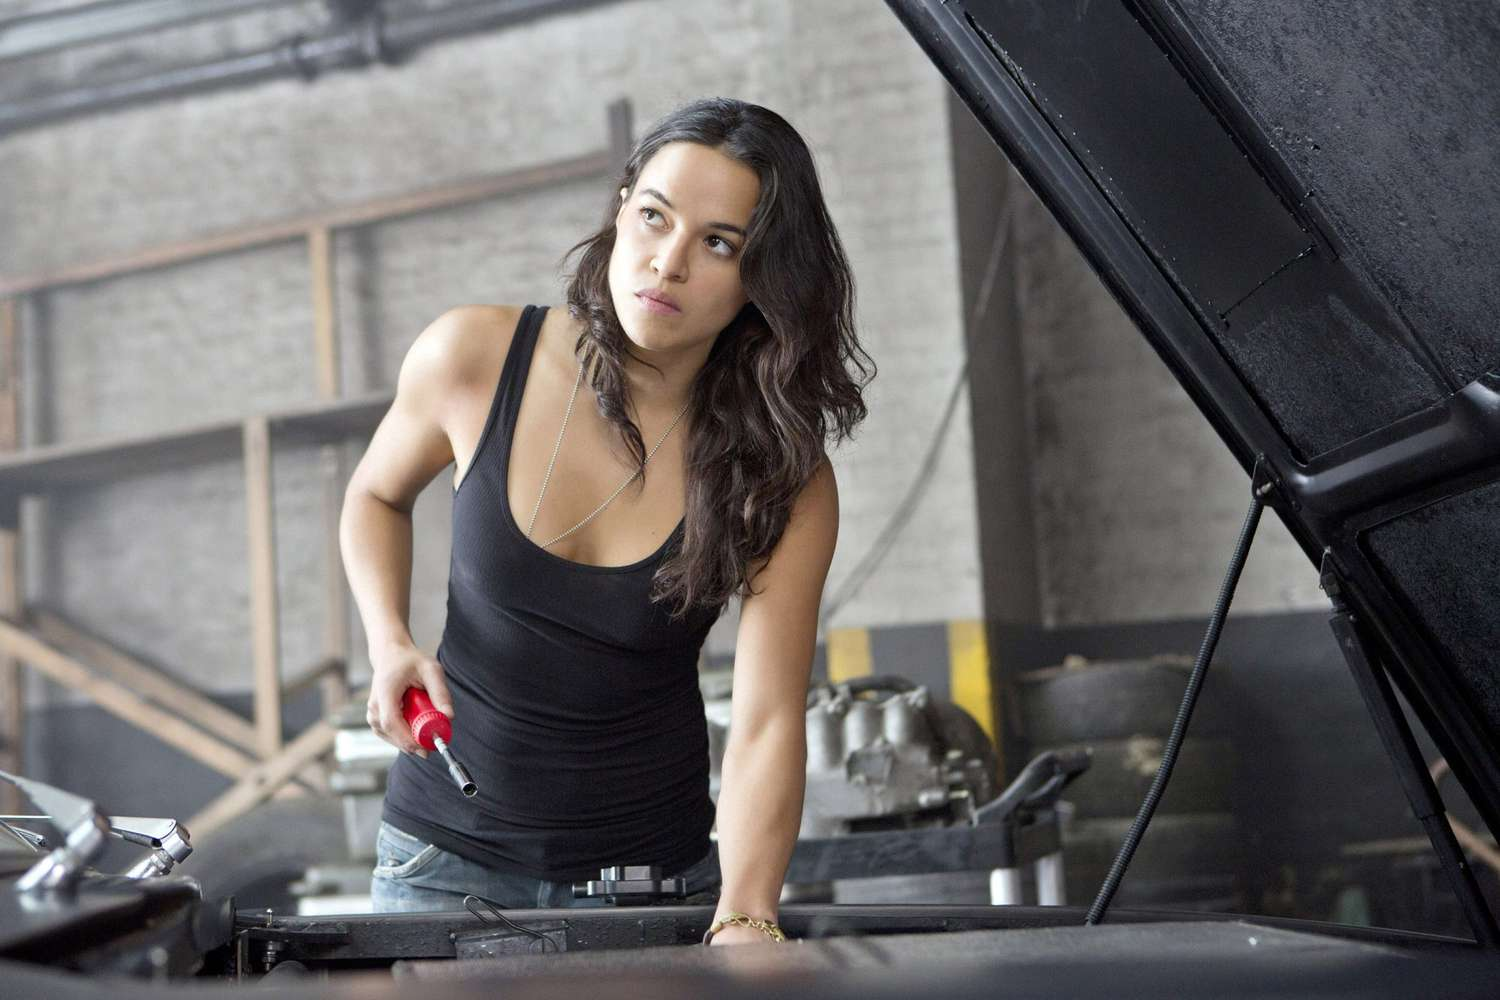What will happen next after she finishes working on the car? After finishing her work on the car, the woman is likely to test the engine, ensuring everything is functioning perfectly. She might take the car for a test drive around the block, paying close attention to its performance. If the car is being prepared for a race or an important event, she could drive it to the venue, eager to see how her hard work pays off. Depending on the outcome, she might either celebrate a job well done or return to the garage for further tweaks and improvements. 